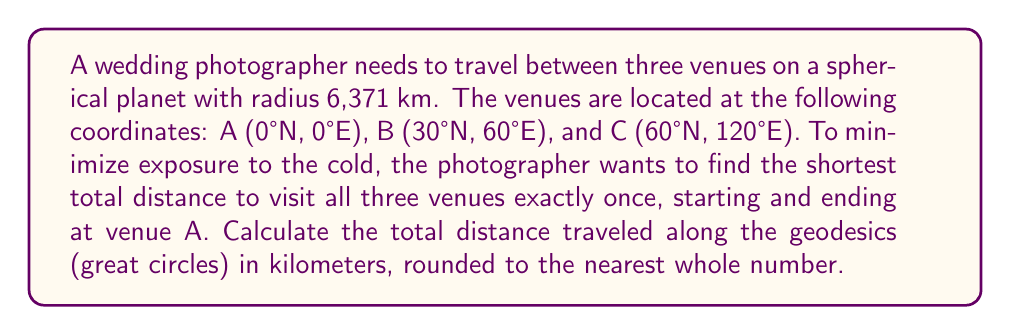Give your solution to this math problem. To solve this problem, we need to follow these steps:

1. Calculate the distances between each pair of venues using the great circle distance formula.
2. Determine the optimal route by comparing the two possible paths: A-B-C-A and A-C-B-A.
3. Sum up the distances for the shorter route.

Step 1: Calculate distances between venues

We'll use the haversine formula to calculate the great circle distance:

$$d = 2R \cdot \arcsin\left(\sqrt{\sin^2\left(\frac{\Delta\phi}{2}\right) + \cos\phi_1 \cos\phi_2 \sin^2\left(\frac{\Delta\lambda}{2}\right)}\right)$$

Where:
- $R$ is the radius of the planet (6,371 km)
- $\phi$ is latitude in radians
- $\lambda$ is longitude in radians

For A-B:
$\phi_1 = 0°, \lambda_1 = 0°, \phi_2 = 30°, \lambda_2 = 60°$
$$d_{AB} = 2 \cdot 6371 \cdot \arcsin\left(\sqrt{\sin^2\left(\frac{30\pi}{360}\right) + \cos(0) \cos\left(\frac{30\pi}{180}\right) \sin^2\left(\frac{60\pi}{360}\right)}\right) = 6,671 \text{ km}$$

For B-C:
$\phi_1 = 30°, \lambda_1 = 60°, \phi_2 = 60°, \lambda_2 = 120°$
$$d_{BC} = 2 \cdot 6371 \cdot \arcsin\left(\sqrt{\sin^2\left(\frac{30\pi}{360}\right) + \cos\left(\frac{30\pi}{180}\right) \cos\left(\frac{60\pi}{180}\right) \sin^2\left(\frac{60\pi}{360}\right)}\right) = 5,585 \text{ km}$$

For A-C:
$\phi_1 = 0°, \lambda_1 = 0°, \phi_2 = 60°, \lambda_2 = 120°$
$$d_{AC} = 2 \cdot 6371 \cdot \arcsin\left(\sqrt{\sin^2\left(\frac{60\pi}{360}\right) + \cos(0) \cos\left(\frac{60\pi}{180}\right) \sin^2\left(\frac{120\pi}{360}\right)}\right) = 10,242 \text{ km}$$

Step 2: Determine the optimal route

Route 1: A-B-C-A
Total distance = $d_{AB} + d_{BC} + d_{AC} = 6,671 + 5,585 + 10,242 = 22,498 \text{ km}$

Route 2: A-C-B-A
Total distance = $d_{AC} + d_{BC} + d_{AB} = 10,242 + 5,585 + 6,671 = 22,498 \text{ km}$

Both routes have the same total distance.

Step 3: Sum up the distances

The total distance traveled is 22,498 km.

Rounding to the nearest whole number: 22,498 km.
Answer: 22,498 km 